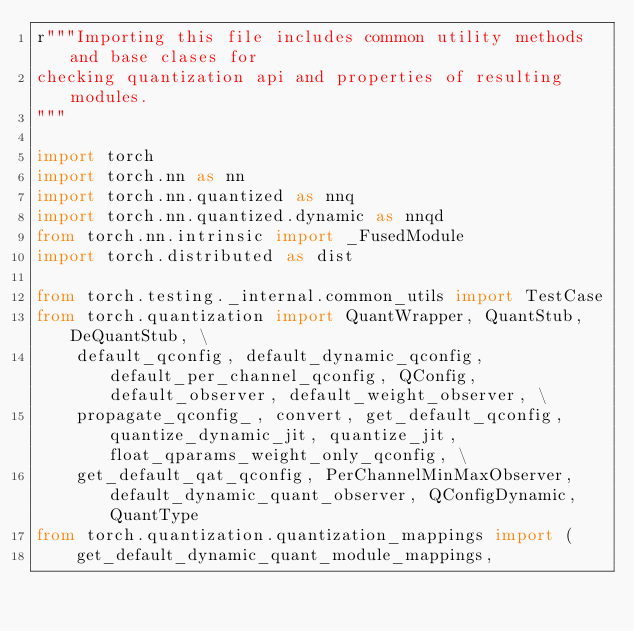Convert code to text. <code><loc_0><loc_0><loc_500><loc_500><_Python_>r"""Importing this file includes common utility methods and base clases for
checking quantization api and properties of resulting modules.
"""

import torch
import torch.nn as nn
import torch.nn.quantized as nnq
import torch.nn.quantized.dynamic as nnqd
from torch.nn.intrinsic import _FusedModule
import torch.distributed as dist

from torch.testing._internal.common_utils import TestCase
from torch.quantization import QuantWrapper, QuantStub, DeQuantStub, \
    default_qconfig, default_dynamic_qconfig, default_per_channel_qconfig, QConfig, default_observer, default_weight_observer, \
    propagate_qconfig_, convert, get_default_qconfig, quantize_dynamic_jit, quantize_jit, float_qparams_weight_only_qconfig, \
    get_default_qat_qconfig, PerChannelMinMaxObserver, default_dynamic_quant_observer, QConfigDynamic, QuantType
from torch.quantization.quantization_mappings import (
    get_default_dynamic_quant_module_mappings,</code> 